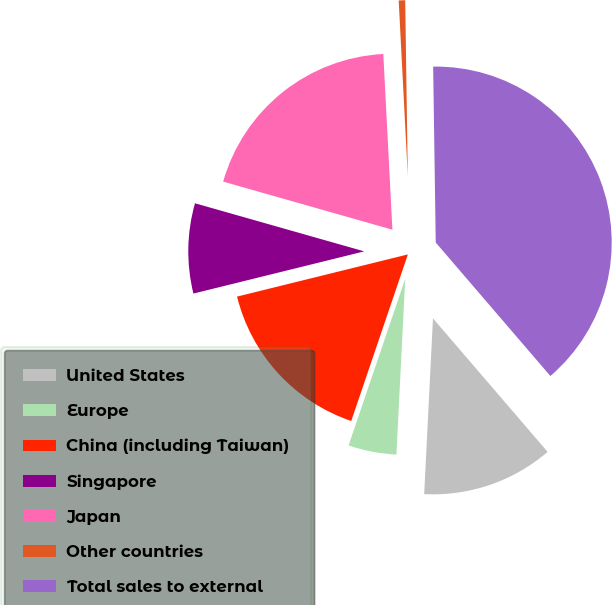Convert chart to OTSL. <chart><loc_0><loc_0><loc_500><loc_500><pie_chart><fcel>United States<fcel>Europe<fcel>China (including Taiwan)<fcel>Singapore<fcel>Japan<fcel>Other countries<fcel>Total sales to external<nl><fcel>12.09%<fcel>4.42%<fcel>15.93%<fcel>8.26%<fcel>19.77%<fcel>0.59%<fcel>38.94%<nl></chart> 